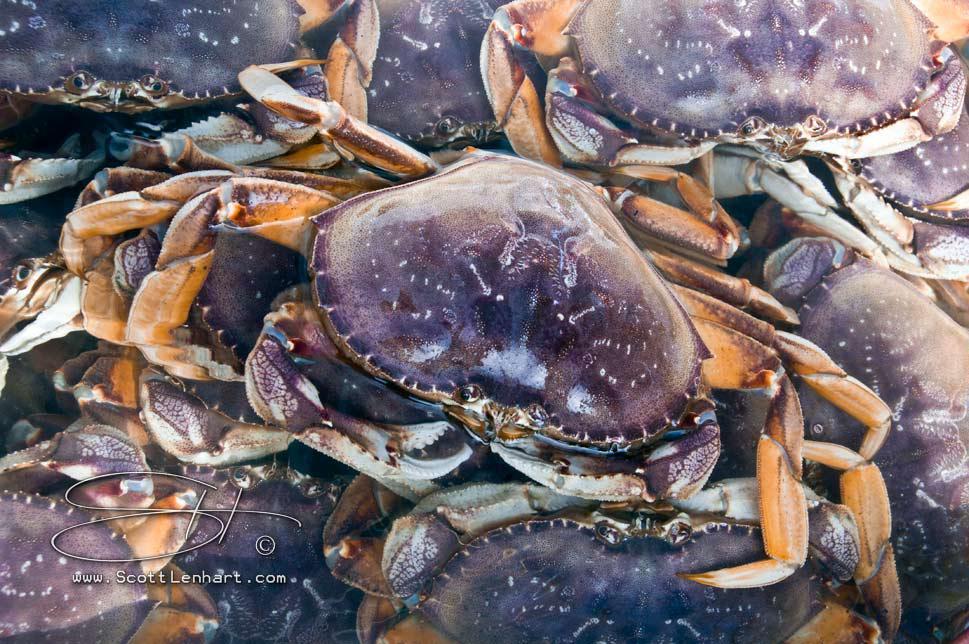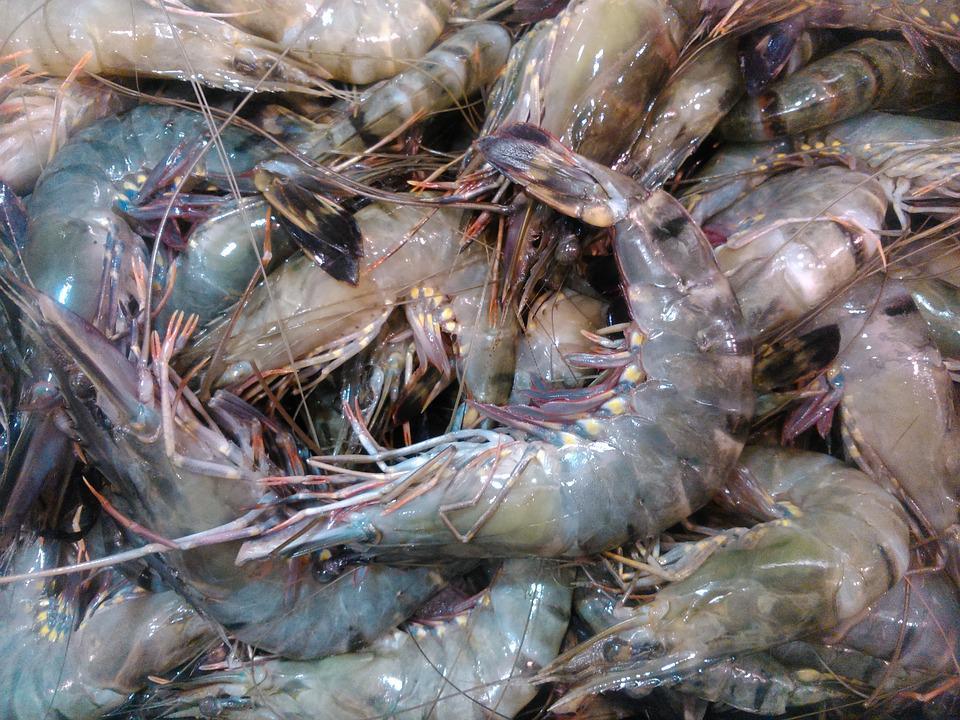The first image is the image on the left, the second image is the image on the right. Considering the images on both sides, is "At least one image shows crabs in a container with a grid of squares and a metal frame." valid? Answer yes or no. No. The first image is the image on the left, the second image is the image on the right. Given the left and right images, does the statement "There are crabs in cages." hold true? Answer yes or no. No. 